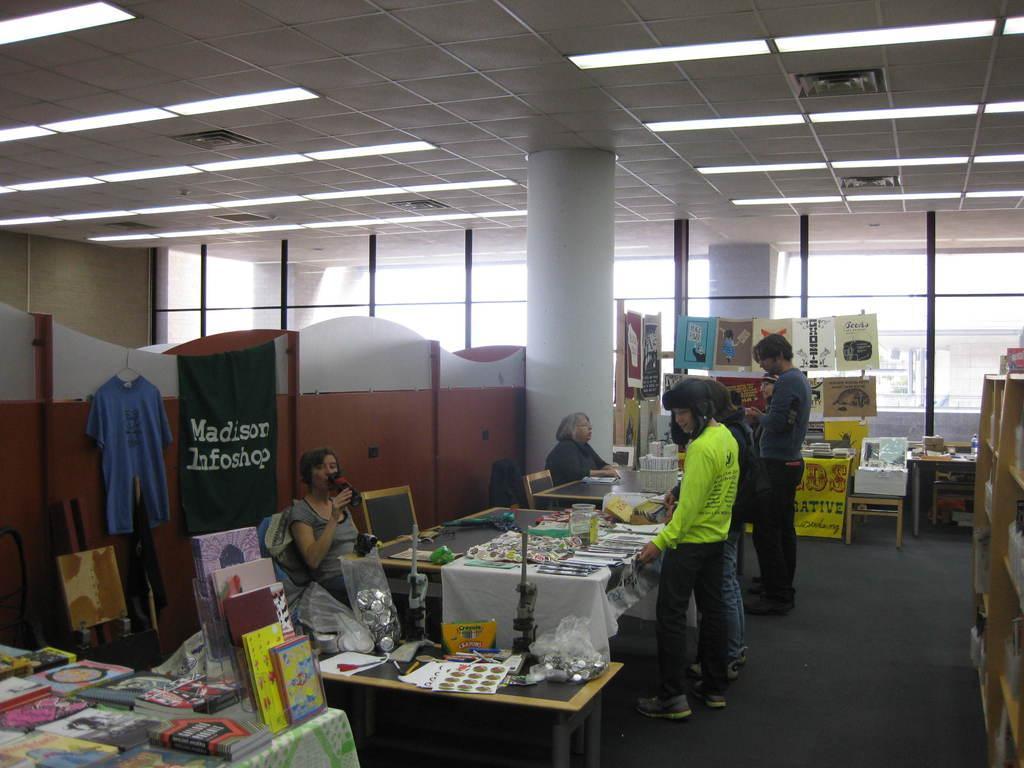Could you give a brief overview of what you see in this image? In this image, There is a floor which is in black color, In the left there are some tables on that there are some objects and there are some people sitting and standing, In the top there is a roof in white and yellow color. 